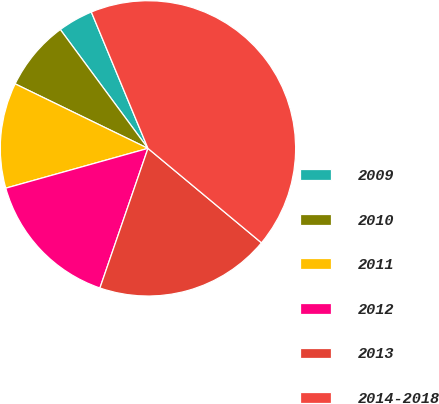<chart> <loc_0><loc_0><loc_500><loc_500><pie_chart><fcel>2009<fcel>2010<fcel>2011<fcel>2012<fcel>2013<fcel>2014-2018<nl><fcel>3.85%<fcel>7.69%<fcel>11.54%<fcel>15.38%<fcel>19.23%<fcel>42.31%<nl></chart> 